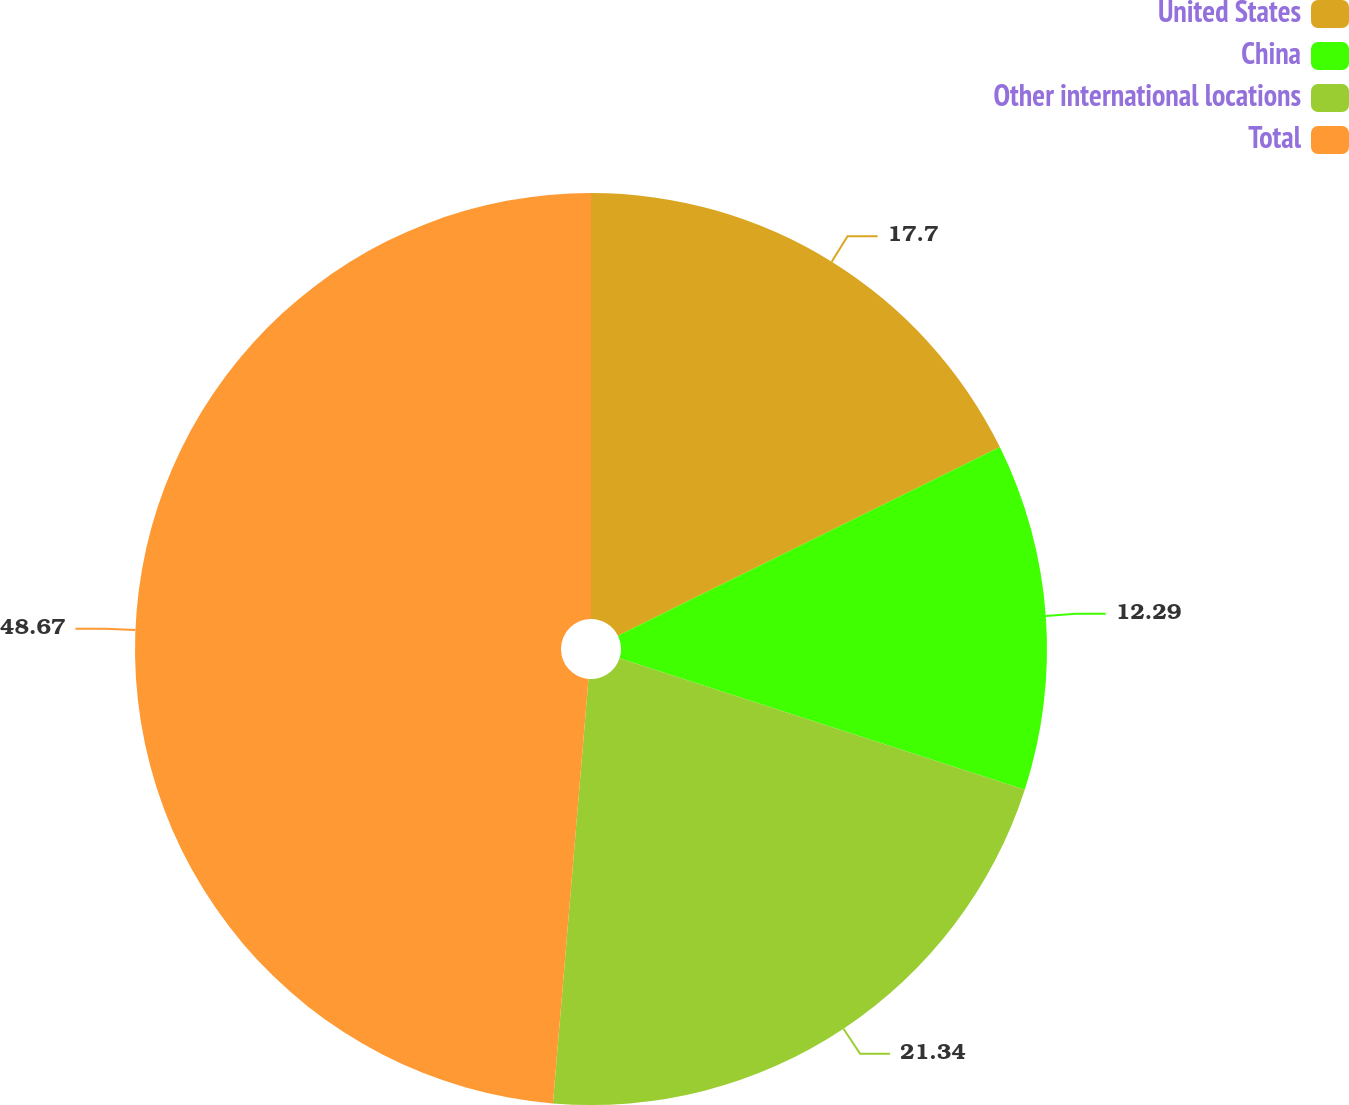<chart> <loc_0><loc_0><loc_500><loc_500><pie_chart><fcel>United States<fcel>China<fcel>Other international locations<fcel>Total<nl><fcel>17.7%<fcel>12.29%<fcel>21.34%<fcel>48.67%<nl></chart> 